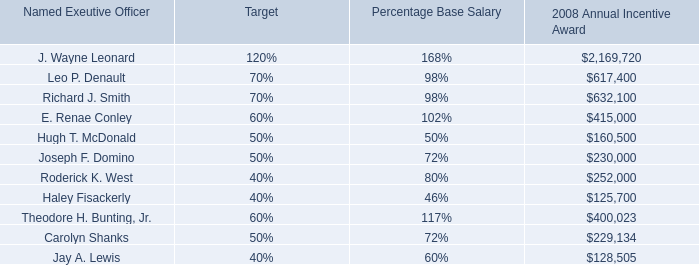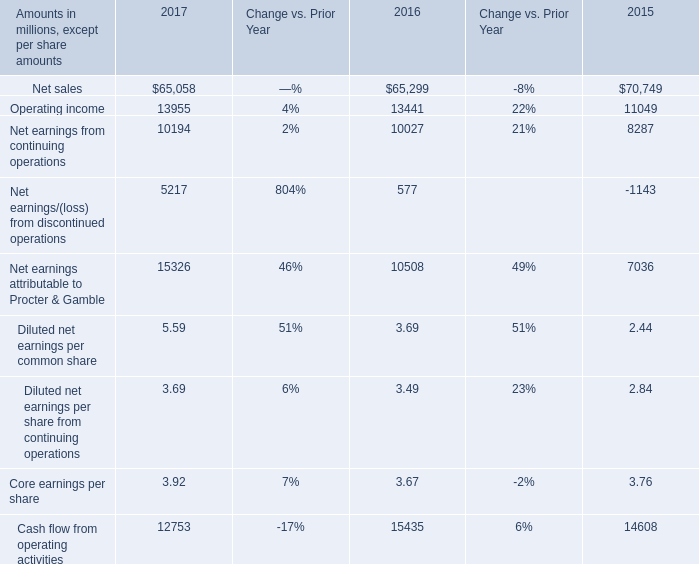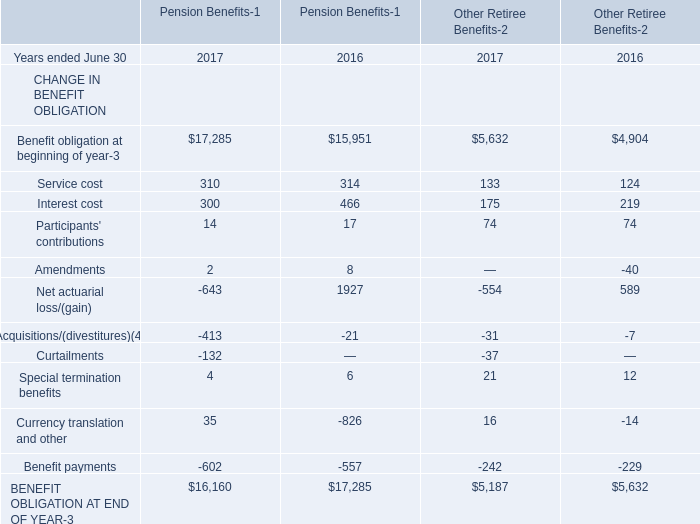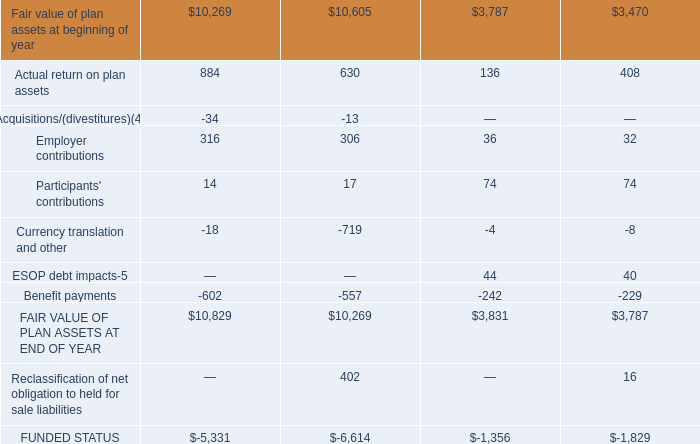what's the total amount of FAIR VALUE OF PLAN ASSETS AT END OF YEAR, Net sales of 2015, and Cash flow from operating activities of 2017 ? 
Computations: ((10829.0 + 70749.0) + 12753.0)
Answer: 94331.0. 